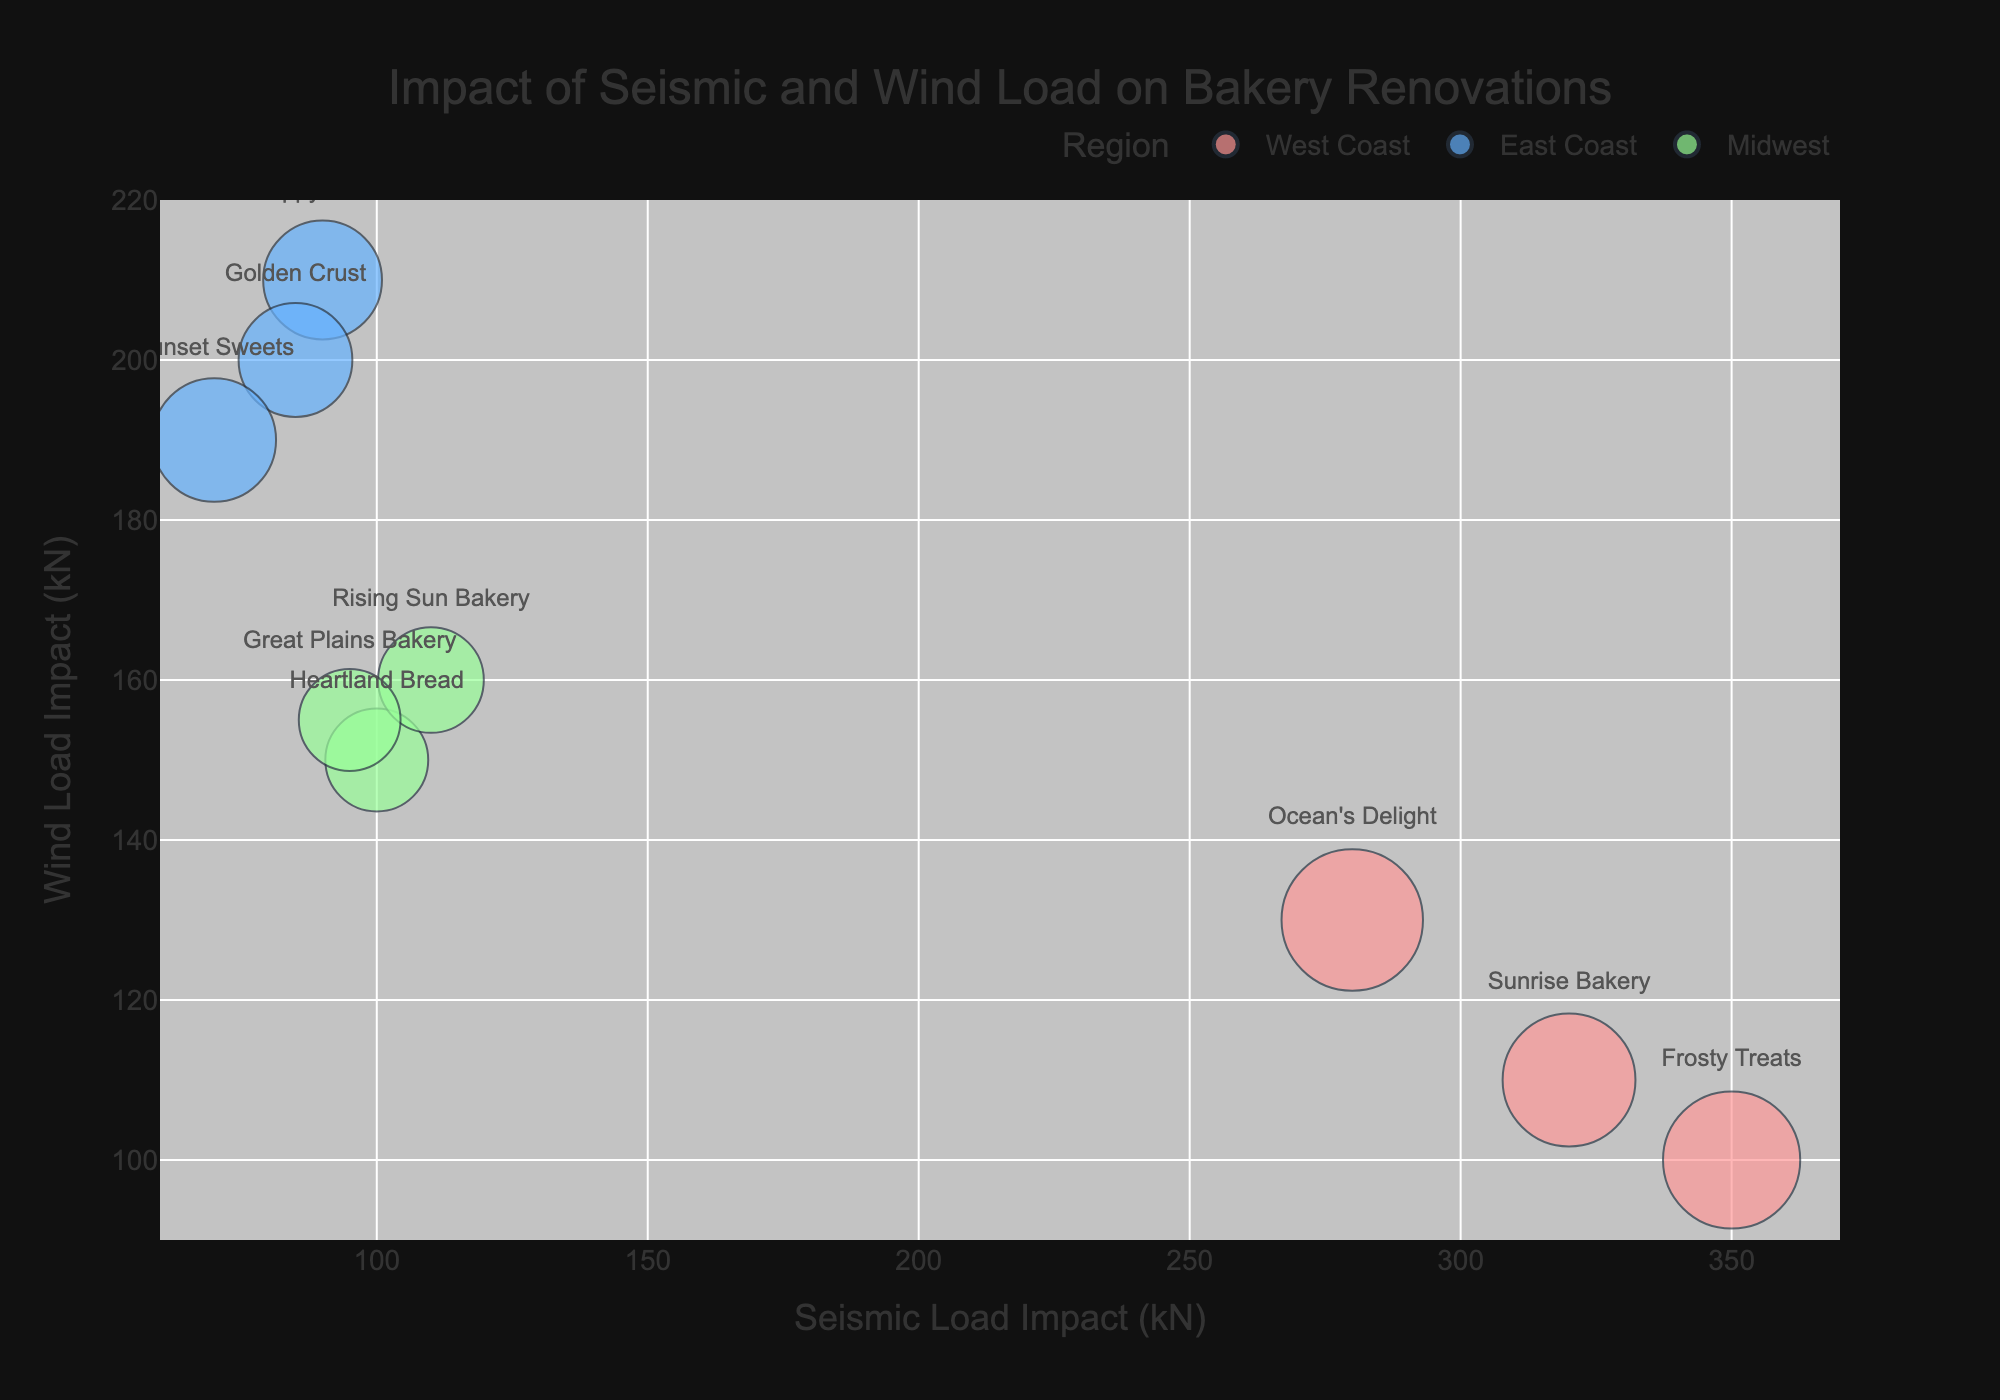Which region has the highest Design Change Cost for bakeries? The size of the bubbles represents the Design Change Cost. The largest bubbles are on the West Coast, indicating the highest Design Change Costs in this region.
Answer: West Coast Which bakery is least impacted by Seismic Load but most affected by Wind Load? Look for the bubble with the lowest x-value (Seismic Load Impact) and the highest y-value (Wind Load Impact). Happy Bakes on the East Coast fits this description.
Answer: Happy Bakes What's the combined Design Change Cost for all bakeries on the Midwest? Summing up the sizes of the bubbles for Midwest bakeries (Heartland Bread $9000, Rising Sun Bakery $9500, and Great Plains Bakery $8800) results in a total of $27,300.
Answer: $27,300 Which region's bakeries show the smallest variation in Seismic Load Impact? The West Coast bakeries range from 280 kN to 350 kN (70 kN difference), East Coast from 70 kN to 90 kN (20 kN difference), and Midwest from 95 kN to 110 kN (15 kN difference). Thus, the East Coast shows the smallest variation in Seismic Load Impact.
Answer: East Coast Which bakery has the highest combined Seismic and Wind Load Impact? Add the x (Seismic Load) and y (Wind Load) values for each bakery, and find the highest sum. Frosty Treats on the West Coast has 350 + 100 = 450 kN, which is the highest.
Answer: Frosty Treats Do West Coast bakeries tend to have higher Seismic Load Impact compared to other regions? Compare the x-values for West Coast bakeries (all above 280 kN) with those of East Coast and Midwest bakeries (all below 110 kN). West Coast bakeries do have higher Seismic Load Impact.
Answer: Yes Which bakery shows the highest daily customer footfall on average? Hover data shows daily footfall, and the bubble for Frosty Treats on the West Coast has the highest average daily footfall of 210.
Answer: Frosty Treats How many bakeries are there in each region? Count the number of bubbles for each color representing a region. West Coast has 3, East Coast has 3, and Midwest has 3.
Answer: 3 for each region Which region's bakeries have the least impact from Wind Load on average? The y-values (Wind Load) for Midwest bakeries range from 150 to 160 kN, which is lower than West Coast and East Coast ranges.
Answer: Midwest 